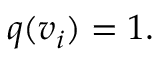Convert formula to latex. <formula><loc_0><loc_0><loc_500><loc_500>q ( v _ { i } ) = 1 .</formula> 